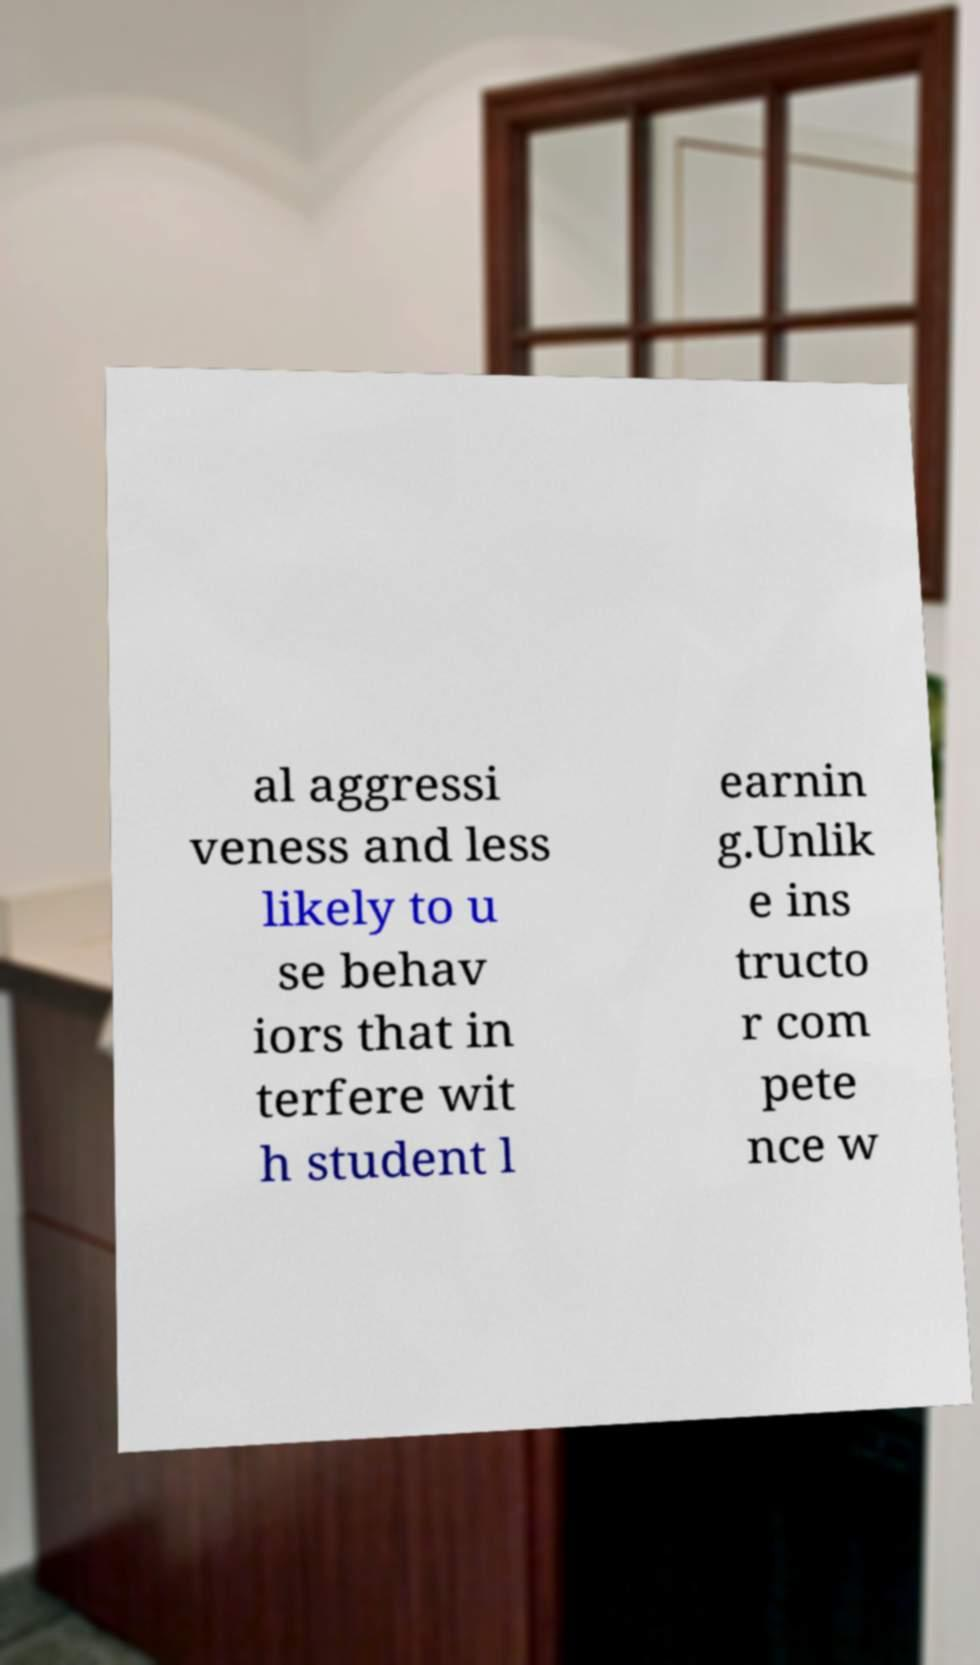Can you read and provide the text displayed in the image?This photo seems to have some interesting text. Can you extract and type it out for me? al aggressi veness and less likely to u se behav iors that in terfere wit h student l earnin g.Unlik e ins tructo r com pete nce w 